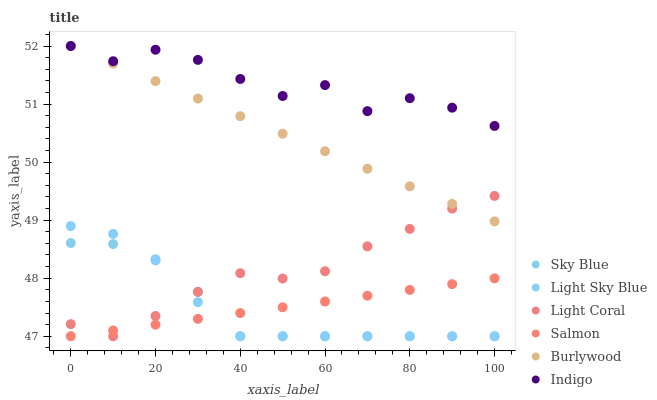Does Sky Blue have the minimum area under the curve?
Answer yes or no. Yes. Does Indigo have the maximum area under the curve?
Answer yes or no. Yes. Does Burlywood have the minimum area under the curve?
Answer yes or no. No. Does Burlywood have the maximum area under the curve?
Answer yes or no. No. Is Salmon the smoothest?
Answer yes or no. Yes. Is Indigo the roughest?
Answer yes or no. Yes. Is Burlywood the smoothest?
Answer yes or no. No. Is Burlywood the roughest?
Answer yes or no. No. Does Salmon have the lowest value?
Answer yes or no. Yes. Does Burlywood have the lowest value?
Answer yes or no. No. Does Burlywood have the highest value?
Answer yes or no. Yes. Does Salmon have the highest value?
Answer yes or no. No. Is Light Sky Blue less than Indigo?
Answer yes or no. Yes. Is Burlywood greater than Salmon?
Answer yes or no. Yes. Does Salmon intersect Light Sky Blue?
Answer yes or no. Yes. Is Salmon less than Light Sky Blue?
Answer yes or no. No. Is Salmon greater than Light Sky Blue?
Answer yes or no. No. Does Light Sky Blue intersect Indigo?
Answer yes or no. No. 